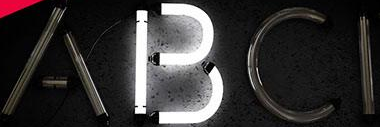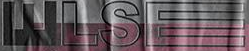Transcribe the words shown in these images in order, separated by a semicolon. ABCI; WLSE 